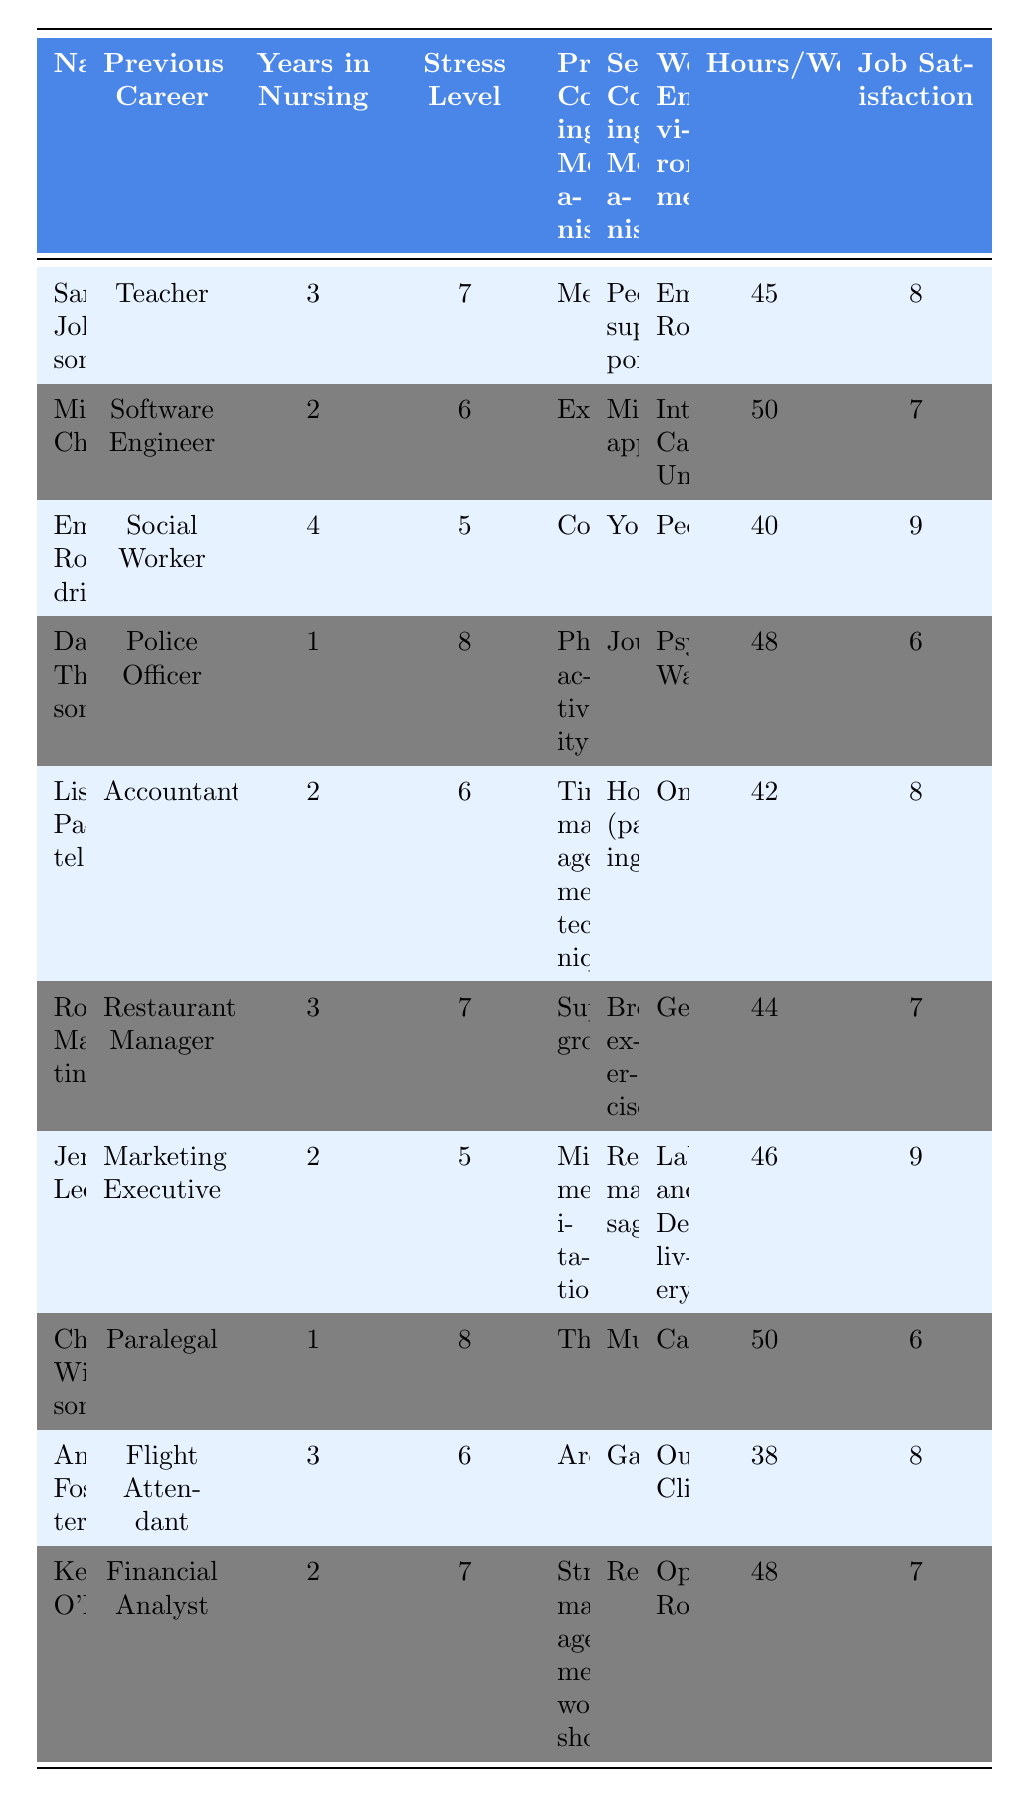What is the highest stress level recorded among the nurses? The highest stress level in the table is observed for David Thompson and Christopher Wilson, both with a score of 8.
Answer: 8 Who has the highest job satisfaction? Emily Rodriguez and Jennifer Lee both have the highest job satisfaction score of 9 in the table.
Answer: 9 Which nurse reported meditation as their primary coping mechanism? Sarah Johnson listed meditation as her primary coping mechanism.
Answer: Sarah Johnson What is the average number of hours worked per week for the nurses in the table? The total hours worked per week is (45 + 50 + 40 + 48 + 42 + 44 + 46 + 50 + 38 + 48) = 462. There are 10 nurses, so the average is 462 / 10 = 46.2 hours.
Answer: 46.2 hours Is there a nurse with a previous career as a police officer? Yes, David Thompson has a previous career as a police officer.
Answer: Yes Which coping mechanisms are used by more than one nurse? The coping mechanisms "Exercise" and "Mindfulness meditation" appear to be used by more than one nurse; specifically, they are not repeated, but others like "Support groups" are mentioned by Robert Martinez alone.
Answer: None (no reuse) What is the difference in stress level between nurses with previous careers in education and engineering? Sarah Johnson (former Teacher) has a stress level of 7, and Michael Chen (former Software Engineer) has a stress level of 6. The difference is 7 - 6 = 1.
Answer: 1 How many years of nursing experience does the nurse with the lowest stress level have? Emily Rodriguez has the lowest stress level of 5 and 4 years of nursing experience.
Answer: 4 years Which work environment has the nurse with the least job satisfaction? The Psychiatric Ward has David Thompson with the least job satisfaction score of 6.
Answer: Psychiatric Ward What is the secondary coping mechanism of Lisa Patel, and is it mentioned by any other nurses? Lisa Patel’s secondary coping mechanism is "Hobby (painting)", which is not mentioned by any other nurses in the table.
Answer: No How does the average stress level compare between nurses who primarily use physical activities versus those who use therapy? David Thompson (physical activity, stress level 8) and Christopher Wilson (therapy, stress level 8) have both equal stress levels. The average for each group is thus (8 + 8) / 2 = 8.
Answer: 8 